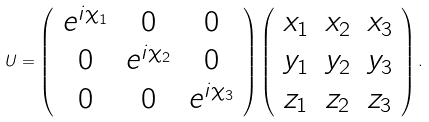Convert formula to latex. <formula><loc_0><loc_0><loc_500><loc_500>U = \left ( \begin{array} { c c c } e ^ { i \chi _ { 1 } } & 0 & 0 \\ 0 & e ^ { i \chi _ { 2 } } & 0 \\ 0 & 0 & e ^ { i \chi _ { 3 } } \end{array} \right ) \left ( \begin{array} { c c c } \text {$x_{1}$} & \text {$x_{2}$} & \text {$x_{3}$} \\ \text {$y_{1}$} & \text {$y_{2}$} & \text {$y_{3}$} \\ \text {$z_{1}$} & \text {$z_{2}$} & \text {$z_{3}$} \end{array} \right ) .</formula> 